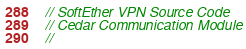<code> <loc_0><loc_0><loc_500><loc_500><_C_>// SoftEther VPN Source Code
// Cedar Communication Module
// </code> 